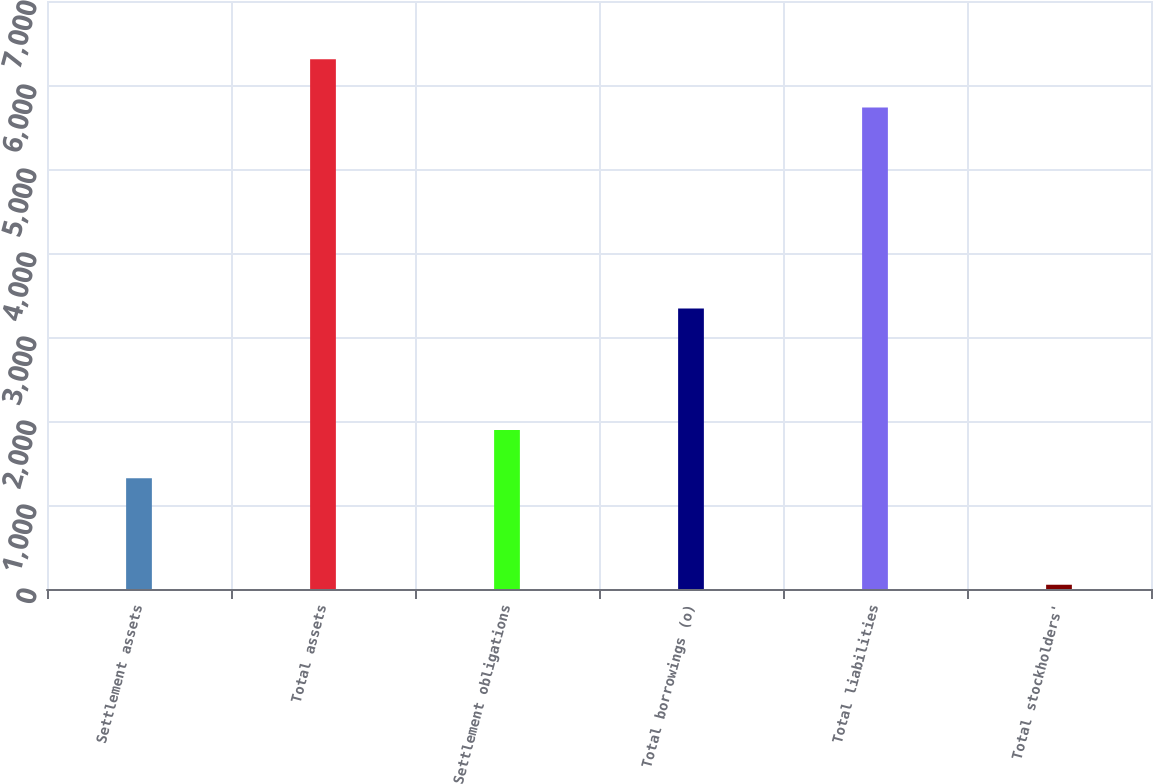Convert chart to OTSL. <chart><loc_0><loc_0><loc_500><loc_500><bar_chart><fcel>Settlement assets<fcel>Total assets<fcel>Settlement obligations<fcel>Total borrowings (o)<fcel>Total liabilities<fcel>Total stockholders'<nl><fcel>1319.2<fcel>6306.85<fcel>1892.55<fcel>3338<fcel>5733.5<fcel>50.7<nl></chart> 